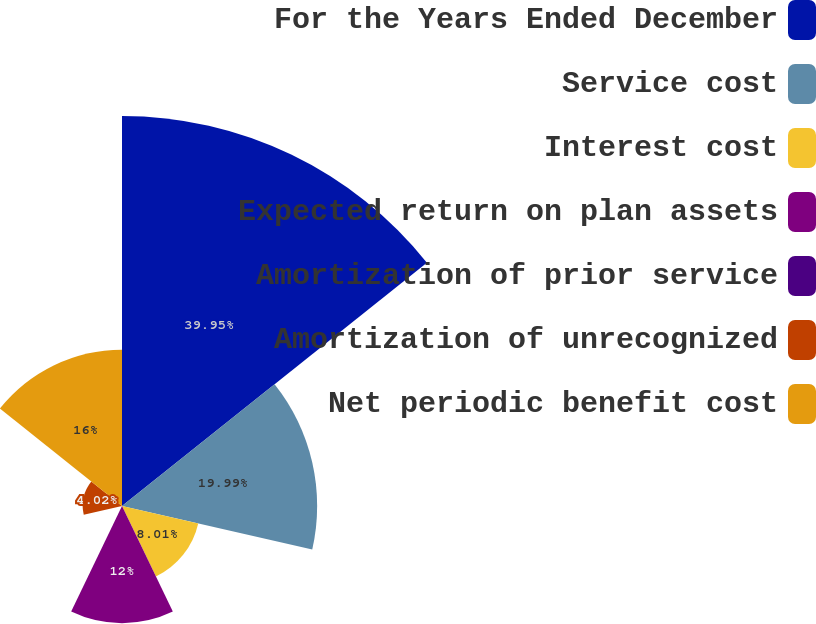Convert chart to OTSL. <chart><loc_0><loc_0><loc_500><loc_500><pie_chart><fcel>For the Years Ended December<fcel>Service cost<fcel>Interest cost<fcel>Expected return on plan assets<fcel>Amortization of prior service<fcel>Amortization of unrecognized<fcel>Net periodic benefit cost<nl><fcel>39.95%<fcel>19.99%<fcel>8.01%<fcel>12.0%<fcel>0.03%<fcel>4.02%<fcel>16.0%<nl></chart> 